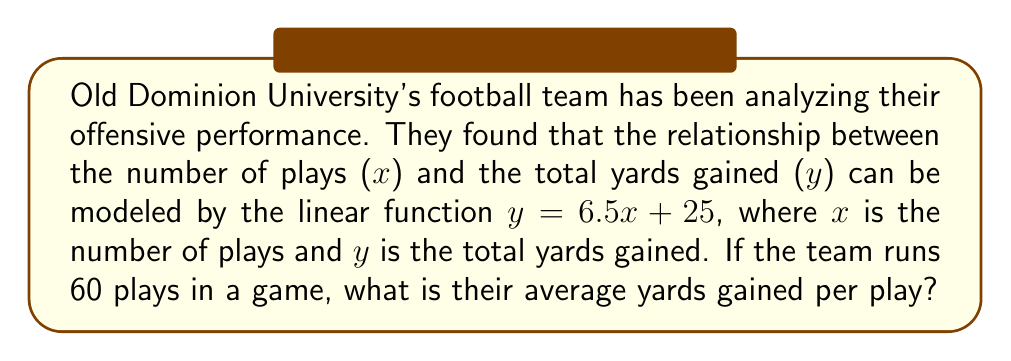Provide a solution to this math problem. To solve this problem, we'll follow these steps:

1) First, let's understand what the linear function $y = 6.5x + 25$ represents:
   - y is the total yards gained
   - x is the number of plays
   - 6.5 is the slope, which represents the average increase in yards per play
   - 25 is the y-intercept, which represents the initial yards (perhaps from penalties or other factors)

2) We need to find the average yards per play when the team runs 60 plays. Let's calculate the total yards for 60 plays:

   $y = 6.5x + 25$
   $y = 6.5(60) + 25$
   $y = 390 + 25 = 415$ yards

3) Now we have:
   - Total plays: 60
   - Total yards: 415

4) To calculate the average yards per play, we divide the total yards by the number of plays:

   Average yards per play = $\frac{\text{Total yards}}{\text{Number of plays}} = \frac{415}{60} = 6.916667$

5) Rounding to two decimal places, we get 6.92 yards per play.

Note: The slope of the linear function (6.5) is close to, but not exactly the same as, the calculated average. This is because the y-intercept (25) adds some initial yards that are then distributed across all plays.
Answer: The average yards gained per play is approximately 6.92 yards. 